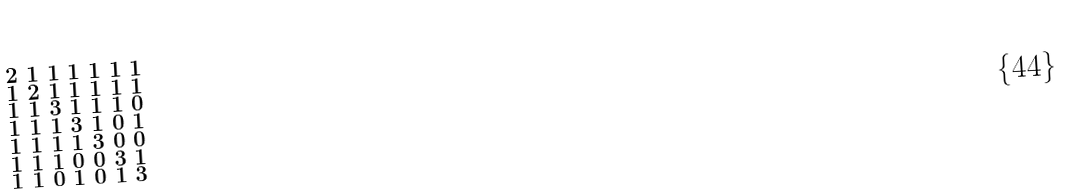<formula> <loc_0><loc_0><loc_500><loc_500>\begin{smallmatrix} 2 & 1 & 1 & 1 & 1 & 1 & 1 \\ 1 & 2 & 1 & 1 & 1 & 1 & 1 \\ 1 & 1 & 3 & 1 & 1 & 1 & 0 \\ 1 & 1 & 1 & 3 & 1 & 0 & 1 \\ 1 & 1 & 1 & 1 & 3 & 0 & 0 \\ 1 & 1 & 1 & 0 & 0 & 3 & 1 \\ 1 & 1 & 0 & 1 & 0 & 1 & 3 \end{smallmatrix}</formula> 